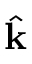Convert formula to latex. <formula><loc_0><loc_0><loc_500><loc_500>\hat { k }</formula> 